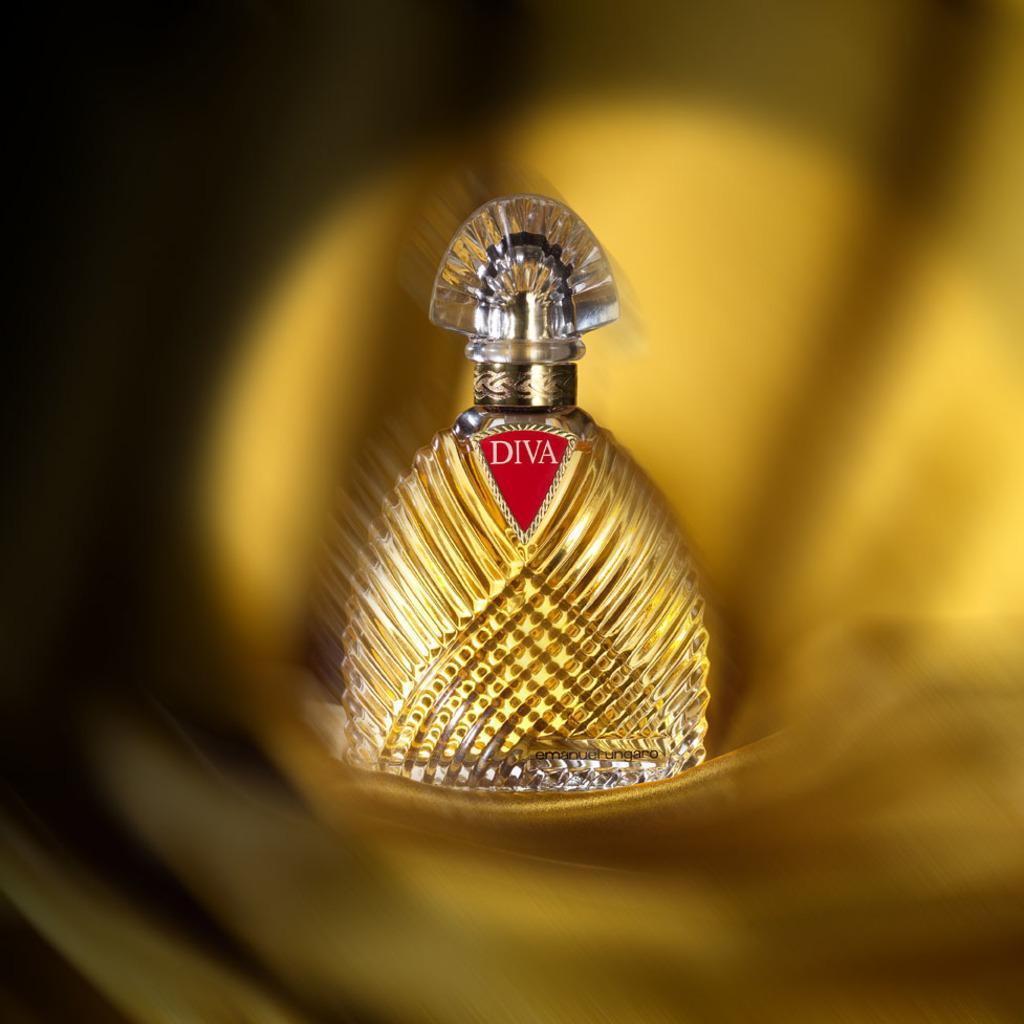How would you summarize this image in a sentence or two? In the middle of the image, there is a bottle having red color logo on it. And the background is blurred. 